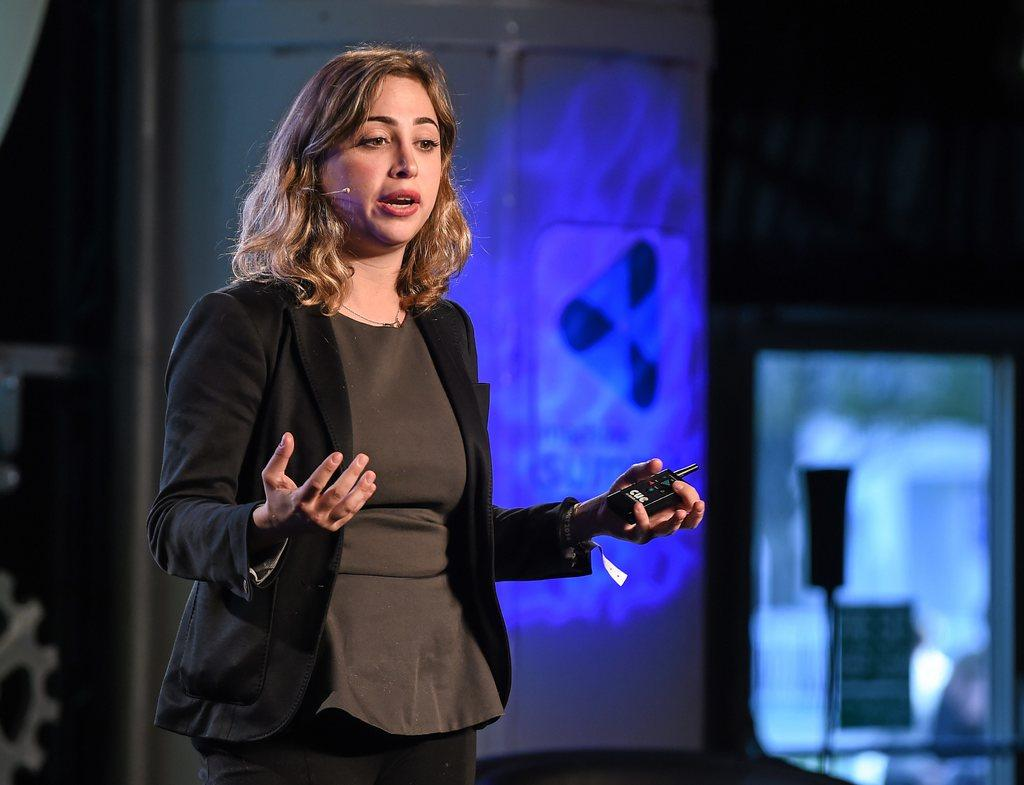Who is the main subject in the image? There is a woman in the image. What is the woman doing in the image? The woman is standing and speaking. What is the woman wearing in the image? The woman is wearing a black blazer. How is the background of the image depicted? The background of the woman is blurred. Can you see any water or frogs in the woman's territory in the image? There is no reference to water, frogs, or territory in the image; it features a woman standing and speaking while wearing a black blazer. 